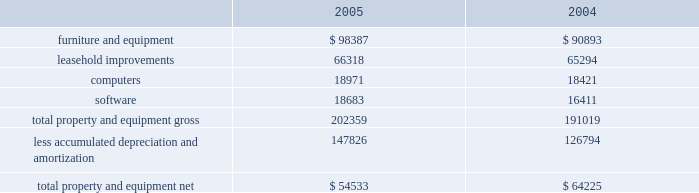Value , which may be maturity , the company does not consider these investments to be other-than-temporarily impaired as of december 31 , 2005 and 2004 .
Gross realized gains and losses for 2005 were $ 15000 and $ 75000 , respectively .
Gross realized gains and losses for 2004 were $ 628000 and $ 205000 , respectively .
Gross realized gains for 2003 were $ 1249000 .
There were no gross realized losses for 2003 .
Maturities stated are effective maturities .
Restricted cash at december 31 , 2005 and 2004 , the company held $ 41482000 and $ 49847000 , respectively , in restricted cash .
At december 31 , 2005 and 2004 the balance was held in deposit with certain banks predominantly to collateralize conditional stand-by letters of credit in the names of the company's landlords pursuant to certain operating lease agreements .
Property and equipment property and equipment consist of the following at december 31 ( in thousands ) : depreciation expense for the years ended december 31 , 2005 , 2004 and 2003 was $ 26307000 , $ 28353000 and $ 27988000 respectively .
In 2005 and 2004 , the company wrote off certain assets that were fully depreciated and no longer utilized .
There was no effect on the company's net property and equipment .
Additionally , the company wrote off or sold certain assets that were not fully depreciated .
The net loss on disposal of those assets was $ 344000 for 2005 and $ 43000 for 2004 .
Investments in accordance with the company's policy , as outlined in note b , "accounting policies" the company assessed its investment in altus pharmaceuticals , inc .
( "altus" ) , which it accounts for using the cost method , and determined that there had not been any adjustments to the fair values of that investment which would indicate a decrease in its fair value below the carrying value that would require the company to write down the investment basis of the asset , as of december 31 , 2005 and december 31 , 2004 .
The company's cost basis carrying value in its outstanding equity and warrants of altus was $ 18863000 at december 31 , 2005 and 2004. .

What was the percentage increase in the carrying vale of the furniture and equipment from 2004 to 2005? 
Computations: ((98387 - 90893) / 90893)
Answer: 0.08245. 